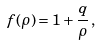<formula> <loc_0><loc_0><loc_500><loc_500>f ( \rho ) = 1 + \frac { q } { \rho } \, ,</formula> 